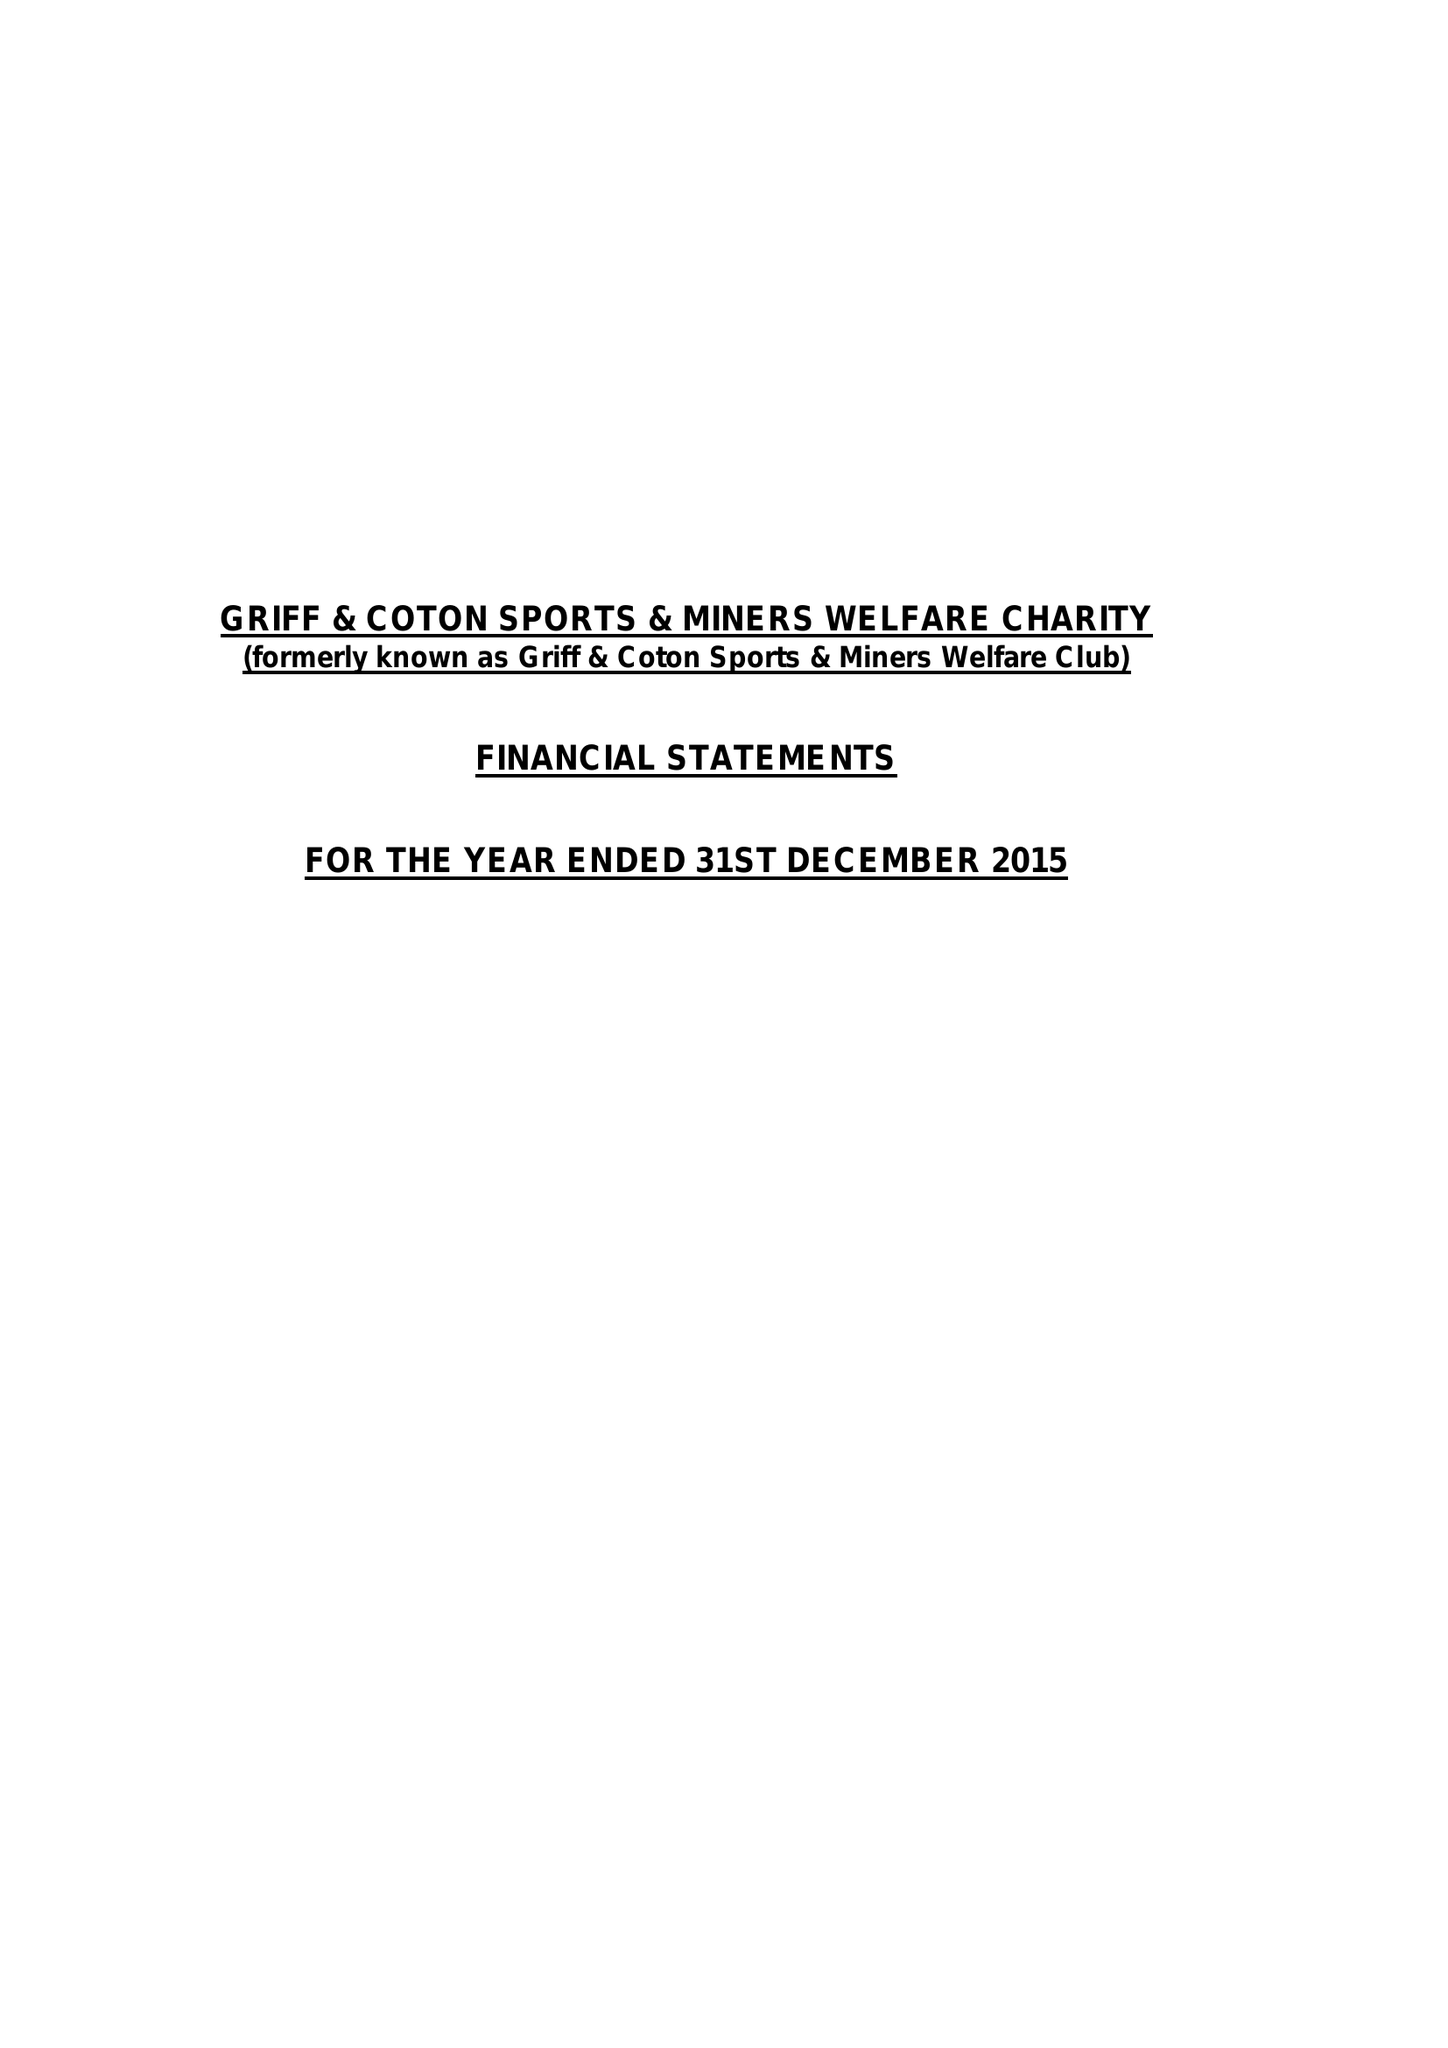What is the value for the charity_name?
Answer the question using a single word or phrase. Griff and Coton Sports and Miners Welfare Charity 